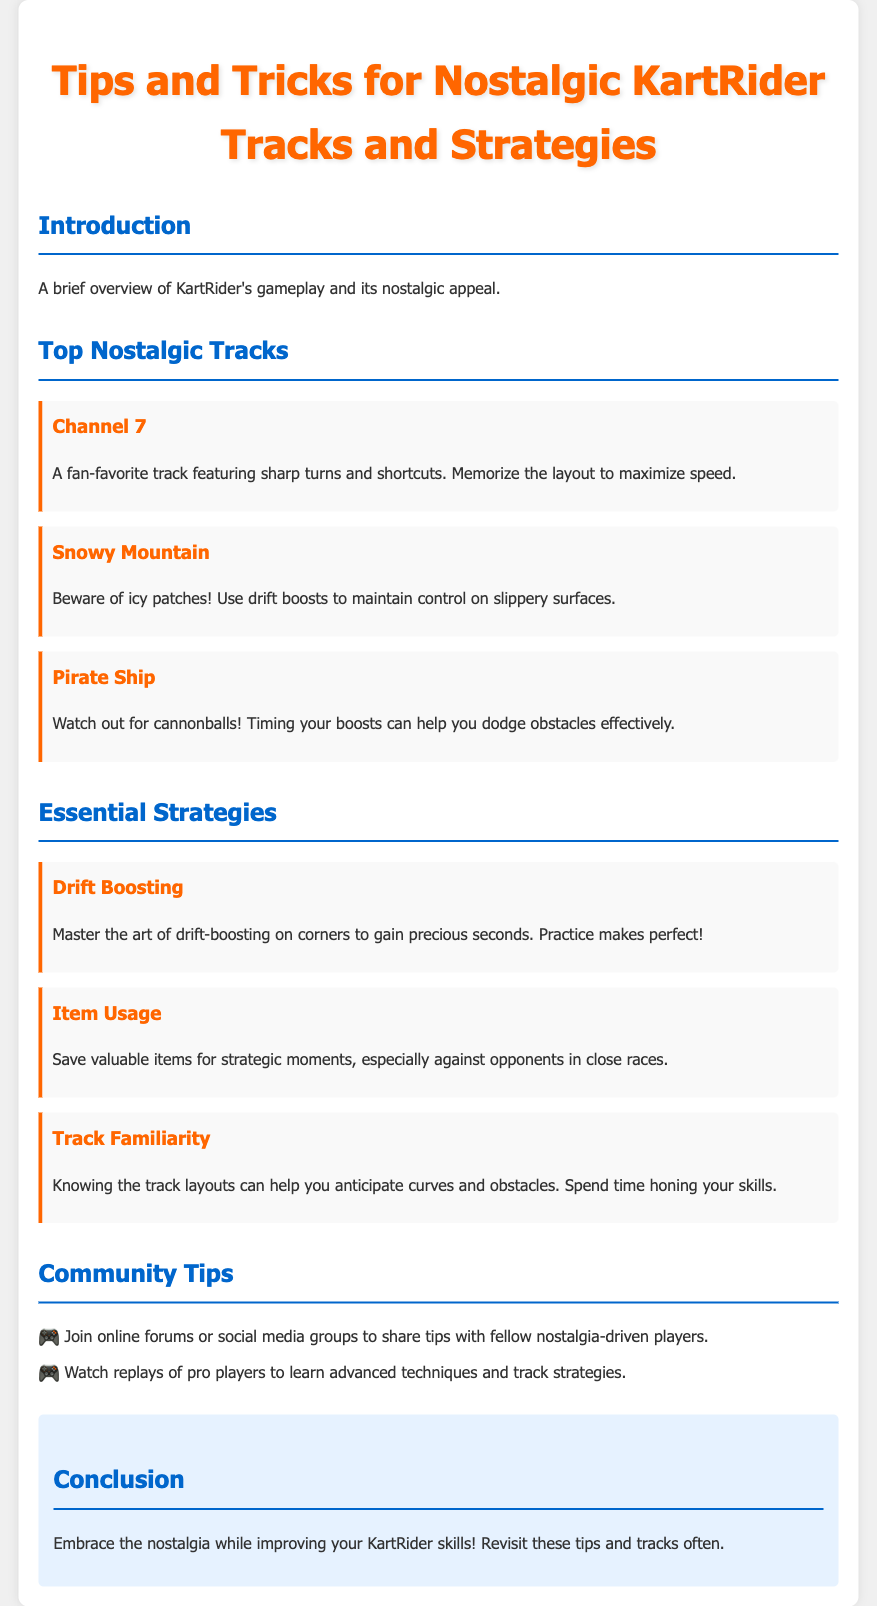What is the title of the document? The title appears at the top of the document and summarizes its content.
Answer: Tips and Tricks for Nostalgic KartRider Tracks and Strategies How many top nostalgic tracks are listed? The document lists three nostalgic tracks in the section dedicated to them.
Answer: 3 What track features icy patches? This information is specified in the description of the relevant track in the document.
Answer: Snowy Mountain What essential strategy involves corners? The document provides a specific strategy that relates to cornering techniques.
Answer: Drift Boosting What should you save valuable items for? This is mentioned in the description of the item usage strategy in the document.
Answer: Strategic moments What color is the conclusion section background? The color of the conclusion section is described in its styling.
Answer: Light blue What is one platform mentioned for sharing tips? The document suggests a method of sharing tips and community engagement.
Answer: Online forums What should players do to improve their skills? The document provides advice on enhancing player skills related to the tracks.
Answer: Revisit these tips and tracks often 